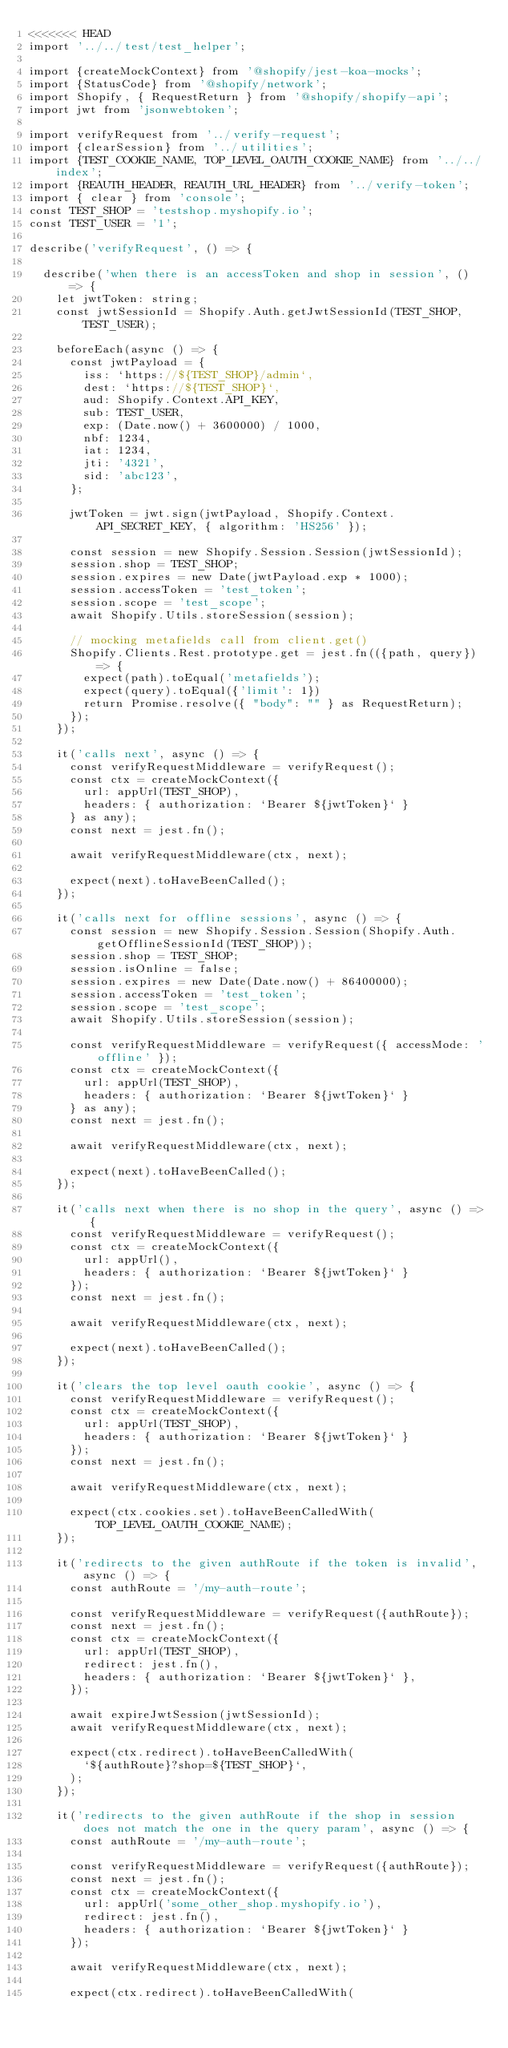<code> <loc_0><loc_0><loc_500><loc_500><_TypeScript_><<<<<<< HEAD
import '../../test/test_helper';

import {createMockContext} from '@shopify/jest-koa-mocks';
import {StatusCode} from '@shopify/network';
import Shopify, { RequestReturn } from '@shopify/shopify-api';
import jwt from 'jsonwebtoken';

import verifyRequest from '../verify-request';
import {clearSession} from '../utilities';
import {TEST_COOKIE_NAME, TOP_LEVEL_OAUTH_COOKIE_NAME} from '../../index';
import {REAUTH_HEADER, REAUTH_URL_HEADER} from '../verify-token';
import { clear } from 'console';
const TEST_SHOP = 'testshop.myshopify.io';
const TEST_USER = '1';

describe('verifyRequest', () => {

  describe('when there is an accessToken and shop in session', () => {
    let jwtToken: string;
    const jwtSessionId = Shopify.Auth.getJwtSessionId(TEST_SHOP, TEST_USER);

    beforeEach(async () => {
      const jwtPayload = {
        iss: `https://${TEST_SHOP}/admin`,
        dest: `https://${TEST_SHOP}`,
        aud: Shopify.Context.API_KEY,
        sub: TEST_USER,
        exp: (Date.now() + 3600000) / 1000,
        nbf: 1234,
        iat: 1234,
        jti: '4321',
        sid: 'abc123',
      };

      jwtToken = jwt.sign(jwtPayload, Shopify.Context.API_SECRET_KEY, { algorithm: 'HS256' });

      const session = new Shopify.Session.Session(jwtSessionId);
      session.shop = TEST_SHOP;
      session.expires = new Date(jwtPayload.exp * 1000);
      session.accessToken = 'test_token';
      session.scope = 'test_scope';
      await Shopify.Utils.storeSession(session);
      
      // mocking metafields call from client.get()
      Shopify.Clients.Rest.prototype.get = jest.fn(({path, query}) => {
        expect(path).toEqual('metafields');
        expect(query).toEqual({'limit': 1})
        return Promise.resolve({ "body": "" } as RequestReturn);
      });
    });

    it('calls next', async () => {
      const verifyRequestMiddleware = verifyRequest();
      const ctx = createMockContext({
        url: appUrl(TEST_SHOP),
        headers: { authorization: `Bearer ${jwtToken}` }
      } as any);
      const next = jest.fn();

      await verifyRequestMiddleware(ctx, next);

      expect(next).toHaveBeenCalled();
    });

    it('calls next for offline sessions', async () => {
      const session = new Shopify.Session.Session(Shopify.Auth.getOfflineSessionId(TEST_SHOP));
      session.shop = TEST_SHOP;
      session.isOnline = false;
      session.expires = new Date(Date.now() + 86400000);
      session.accessToken = 'test_token';
      session.scope = 'test_scope';
      await Shopify.Utils.storeSession(session);

      const verifyRequestMiddleware = verifyRequest({ accessMode: 'offline' });
      const ctx = createMockContext({
        url: appUrl(TEST_SHOP),
        headers: { authorization: `Bearer ${jwtToken}` }
      } as any);
      const next = jest.fn();

      await verifyRequestMiddleware(ctx, next);

      expect(next).toHaveBeenCalled();
    });

    it('calls next when there is no shop in the query', async () => {
      const verifyRequestMiddleware = verifyRequest();
      const ctx = createMockContext({
        url: appUrl(),
        headers: { authorization: `Bearer ${jwtToken}` }
      });
      const next = jest.fn();

      await verifyRequestMiddleware(ctx, next);

      expect(next).toHaveBeenCalled();
    });

    it('clears the top level oauth cookie', async () => {
      const verifyRequestMiddleware = verifyRequest();
      const ctx = createMockContext({
        url: appUrl(TEST_SHOP),
        headers: { authorization: `Bearer ${jwtToken}` }
      });
      const next = jest.fn();

      await verifyRequestMiddleware(ctx, next);

      expect(ctx.cookies.set).toHaveBeenCalledWith(TOP_LEVEL_OAUTH_COOKIE_NAME);
    });

    it('redirects to the given authRoute if the token is invalid', async () => {
      const authRoute = '/my-auth-route';

      const verifyRequestMiddleware = verifyRequest({authRoute});
      const next = jest.fn();
      const ctx = createMockContext({
        url: appUrl(TEST_SHOP),
        redirect: jest.fn(),
        headers: { authorization: `Bearer ${jwtToken}` },
      });

      await expireJwtSession(jwtSessionId);
      await verifyRequestMiddleware(ctx, next);

      expect(ctx.redirect).toHaveBeenCalledWith(
        `${authRoute}?shop=${TEST_SHOP}`,
      );
    });

    it('redirects to the given authRoute if the shop in session does not match the one in the query param', async () => {
      const authRoute = '/my-auth-route';

      const verifyRequestMiddleware = verifyRequest({authRoute});
      const next = jest.fn();
      const ctx = createMockContext({
        url: appUrl('some_other_shop.myshopify.io'),
        redirect: jest.fn(),
        headers: { authorization: `Bearer ${jwtToken}` }
      });

      await verifyRequestMiddleware(ctx, next);

      expect(ctx.redirect).toHaveBeenCalledWith(</code> 